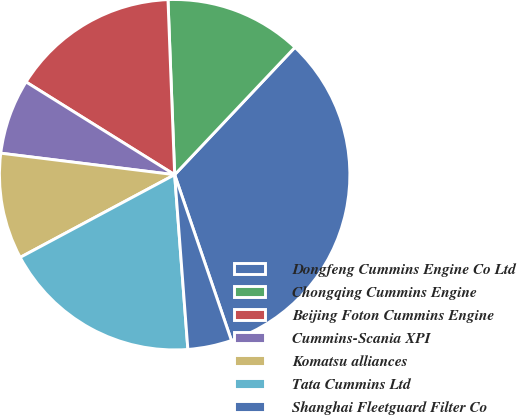Convert chart to OTSL. <chart><loc_0><loc_0><loc_500><loc_500><pie_chart><fcel>Dongfeng Cummins Engine Co Ltd<fcel>Chongqing Cummins Engine<fcel>Beijing Foton Cummins Engine<fcel>Cummins-Scania XPI<fcel>Komatsu alliances<fcel>Tata Cummins Ltd<fcel>Shanghai Fleetguard Filter Co<nl><fcel>32.7%<fcel>12.65%<fcel>15.51%<fcel>6.92%<fcel>9.78%<fcel>18.38%<fcel>4.05%<nl></chart> 